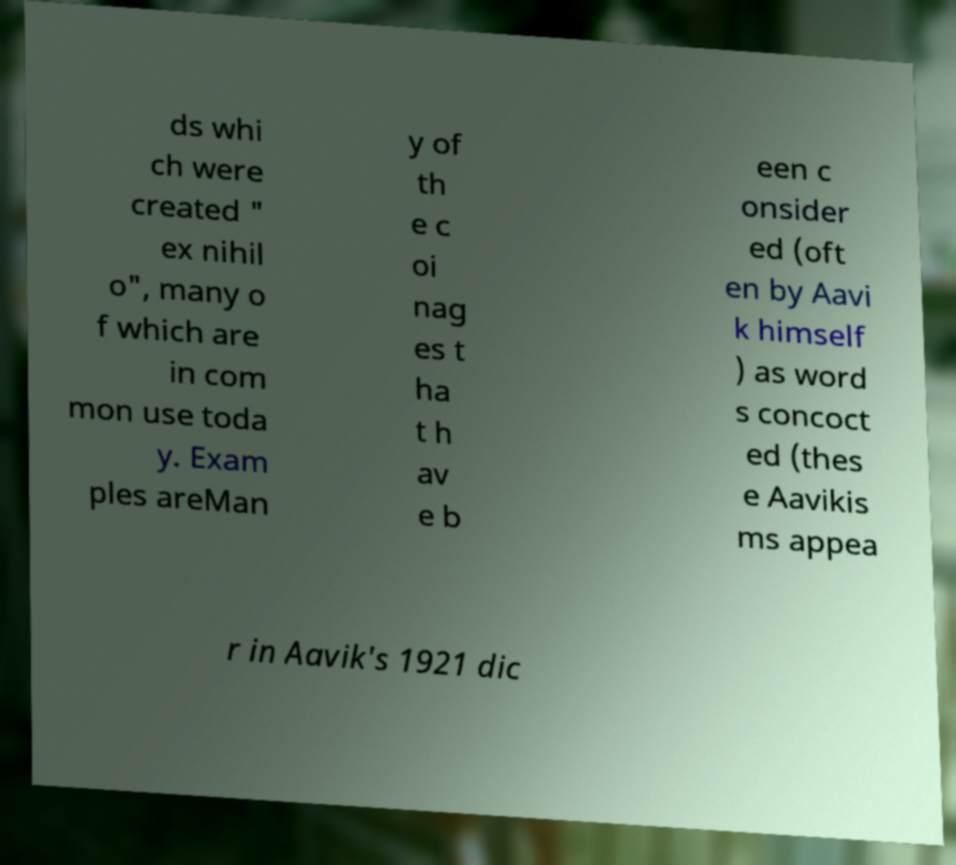Could you assist in decoding the text presented in this image and type it out clearly? ds whi ch were created " ex nihil o", many o f which are in com mon use toda y. Exam ples areMan y of th e c oi nag es t ha t h av e b een c onsider ed (oft en by Aavi k himself ) as word s concoct ed (thes e Aavikis ms appea r in Aavik's 1921 dic 